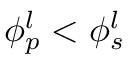<formula> <loc_0><loc_0><loc_500><loc_500>\phi _ { p } ^ { l } < \phi _ { s } ^ { l }</formula> 